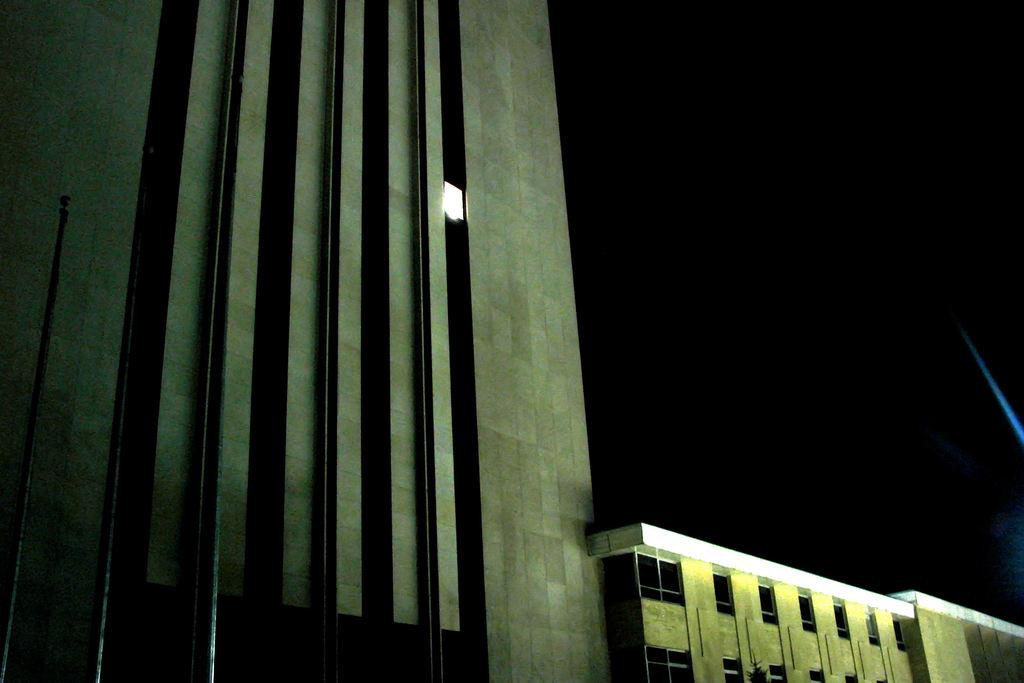What is the main subject in the center of the image? There are buildings in the center of the image. What can be seen at the top of the image? The sky is visible at the top of the image. Where is the pole located in the image? The pole is on the left side of the image. Can you describe the discussion taking place near the pole in the image? There is no discussion present in the image; it only features buildings, the sky, and a pole. What type of appliance can be seen floating in the ocean in the image? There is no ocean or appliance present in the image. 